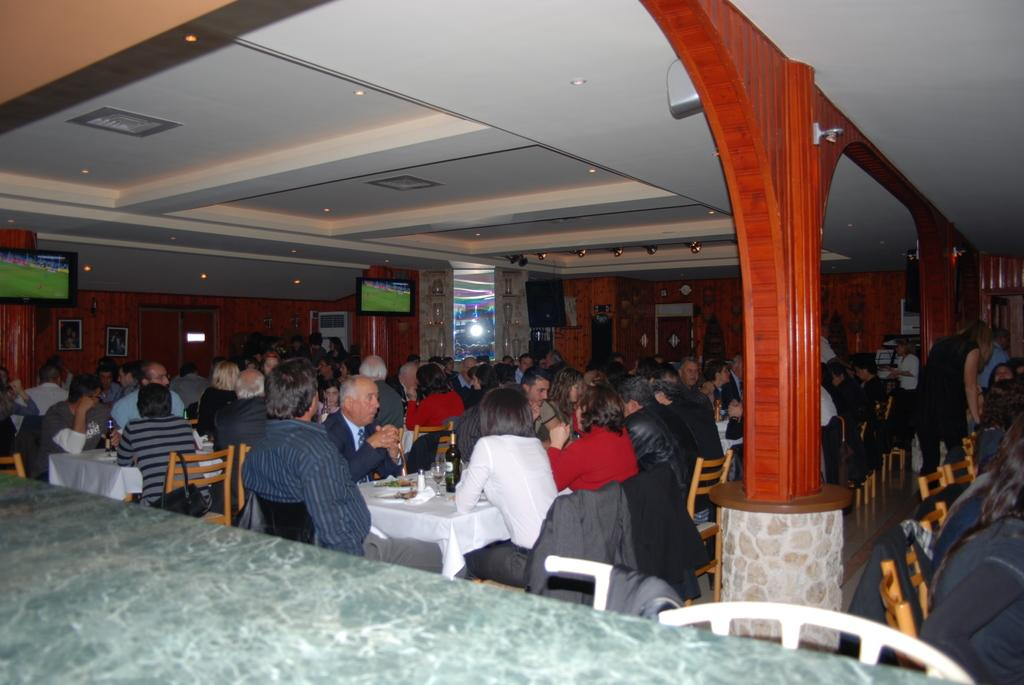How many people are in the image? There are a group of persons in the image. What are the persons doing in the image? The persons are sitting around the tables. Where does the scene take place? The scene takes place in a room. What can be seen in the background of the image? There is a T.V., paintings, and a cooler in the background of the image. What decision can be seen being made by the boys in the image? There are no boys present in the image, and no decision-making process is depicted. 